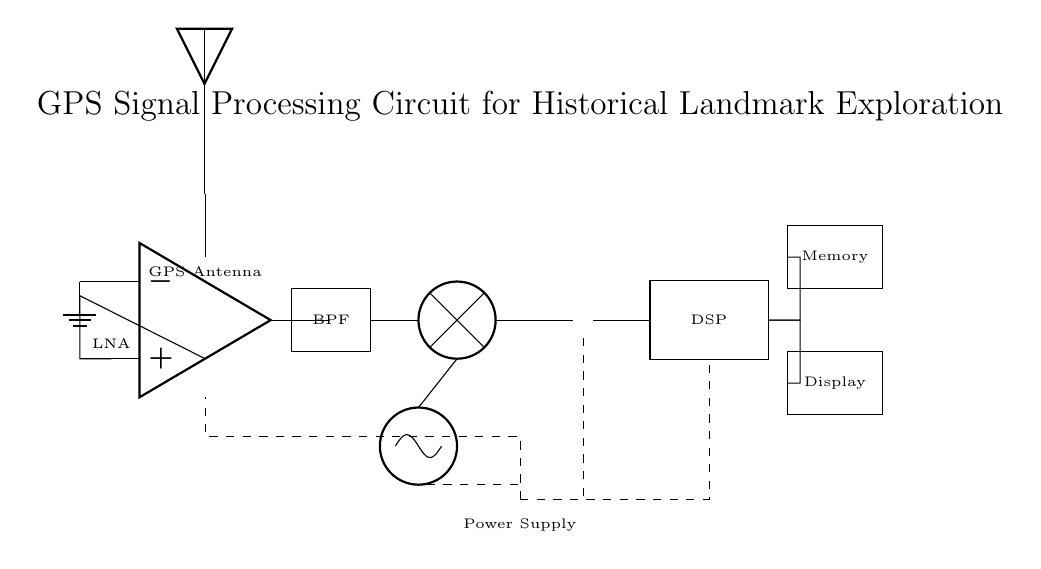What component is used to amplify the GPS signal? The component used to amplify the GPS signal is the Low Noise Amplifier, indicated in the circuit by the label "LNA". It is positioned directly below the GPS Antenna in the diagram.
Answer: Low Noise Amplifier What type of filter is used in this circuit? The circuit uses a Bandpass Filter, as indicated by the rectangle labeled "BPF". Bandpass filters allow signals within a certain frequency range to pass while attenuating others.
Answer: Bandpass Filter How does the Local Oscillator connect to the Mixer? The Local Oscillator connects to the Mixer via a line drawn from the oscillator to the south connection of the mixer. This connection likely facilitates frequency mixing in the circuit.
Answer: Through a direct connection How many stages are there in the signal processing of this circuit? There are five main stages in this circuit: the Low Noise Amplifier, the Bandpass Filter, the Mixer, the Analog-to-Digital Converter (ADC), and the Digital Signal Processor (DSP). Each stage processes the signal further for accurate location tracking.
Answer: Five stages What is the purpose of the Memory component? The Memory component stores processed data from the Digital Signal Processor (DSP), allowing the device to keep track of location data, historical information, or system state necessary for tracking while exploring landmarks.
Answer: Data storage What kind of power source is depicted in this circuit? The circuit depicts a Battery as the power supply, shown at the bottom with a label indicating it provides power to various components in the circuit.
Answer: Battery What is the role of the Digital Signal Processor in this circuit? The Digital Signal Processor receives data from the ADC and performs advanced signal processing tasks, such as filtering and interpreting the GPS signals to derive accurate location information necessary for historical exploration.
Answer: Signal processing 